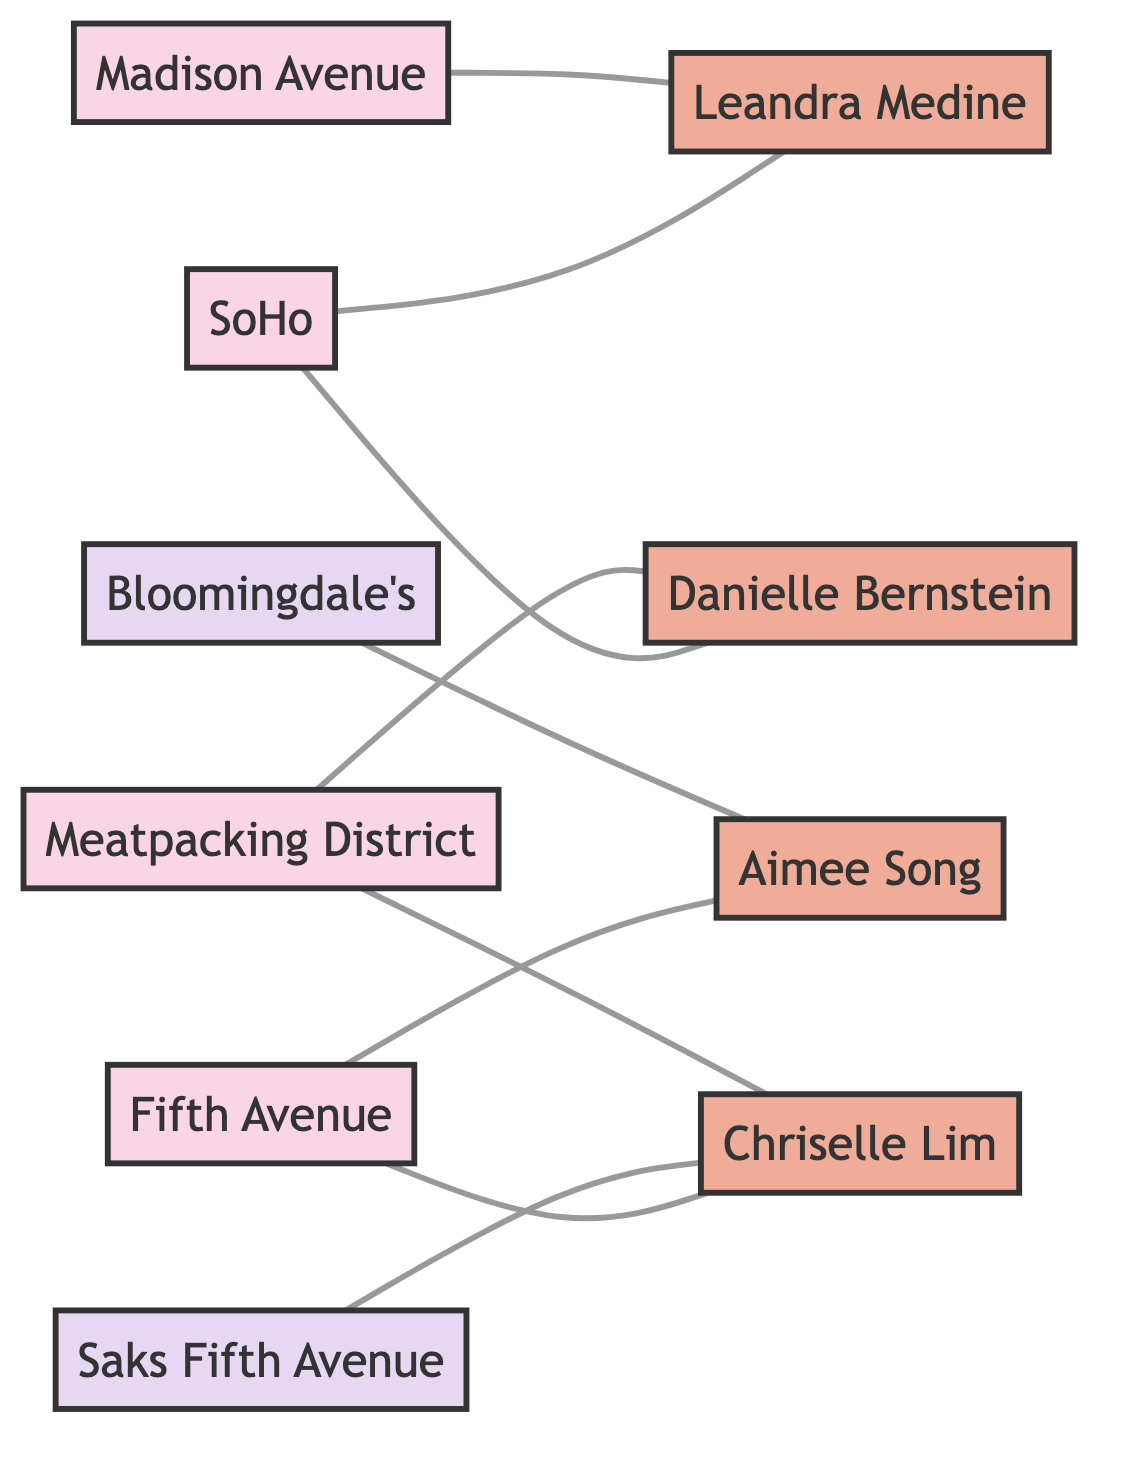What shopping district is associated with Leandra Medine? Leandra Medine is connected to two shopping districts: SoHo and Madison Avenue. To identify the first district, we can check the edges from the "Leandra Medine" node, and we find a connection to "SoHo." Thus, "SoHo" is the answer.
Answer: SoHo How many fashion influencers are connected to Fifth Avenue? To find the number of fashion influencers associated with Fifth Avenue, we look at the edges connected to the "Fifth Avenue" node. There are two edges leading from this district to the influencers Aimee Song and Chriselle Lim. Hence, we count two influencers.
Answer: 2 Which shopping district connects to both Danielle Bernstein and Chriselle Lim? We first identify the edges leading from Danielle Bernstein and find it connects to SoHo and Meatpacking District. Then we look for connections from Chriselle Lim and see that one of her districts is Meatpacking District. Therefore, the common connection is the Meatpacking District.
Answer: Meatpacking District Name one store located on Madison Avenue. The diagram shows that the "Madison Avenue" is connected solely to the influencer Leandra Medine and does not indicate direct store connections. However, since this district typically houses high-end stores, we can infer that Leandra Medine has relationships based on the style of shopping there, but no specific store designated in this diagram.
Answer: None What is the total number of nodes in the diagram? To determine the total number of nodes, we simply count all distinct nodes provided in the data under the "nodes" section: SoHo, Fifth Avenue, Meatpacking District, Madison Avenue, Bloomingdale's, Saks Fifth Avenue, Leandra Medine, Danielle Bernstein, Aimee Song, Chriselle Lim. There are ten nodes in total.
Answer: 10 Which influencers are connected to the Bloomingdale's? Checking the edges, we see that there is a direct connection from "Bloomingdale's" to "Aimee Song." There are no other influencers associated with this store in the diagram, resulting in only one influencer linked to Bloomingdale's.
Answer: Aimee Song How many shopping districts are connected to Chriselle Lim? Looking at the edges connected to Chriselle Lim, we identify two districts: Fifth Avenue and Meatpacking District. Therefore, she is linked to two shopping districts.
Answer: 2 Which influencer is uniquely associated with SoHo? From the edges, we see that both Leandra Medine and Danielle Bernstein are connected specifically to SoHo. However, since the question asks for an influencer uniquely associated with SoHo, we note there are two influencers associated. Hence, there are no unique associations here regarding only one influencer present there.
Answer: None 